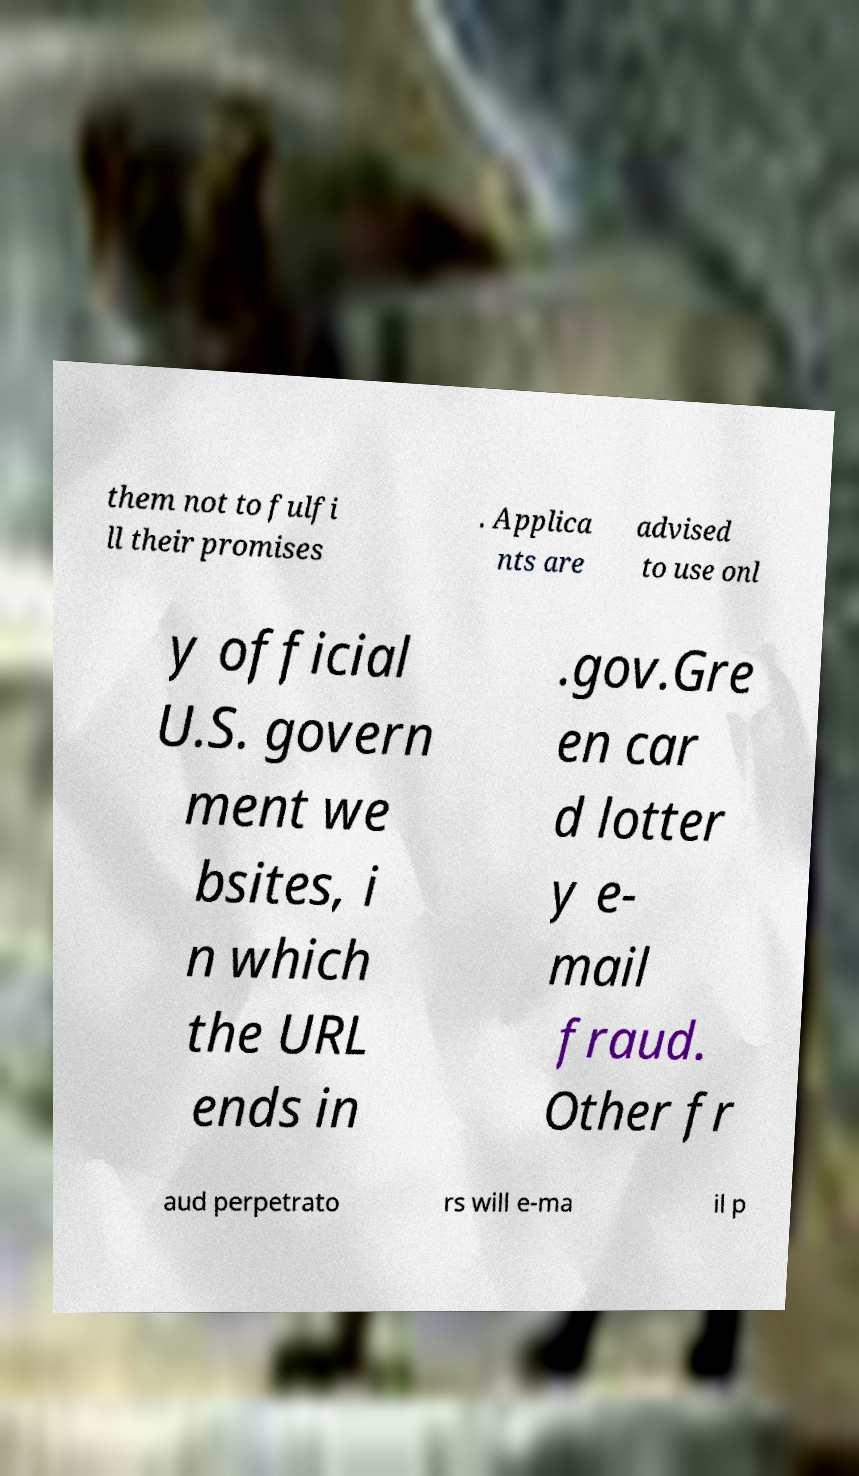Please read and relay the text visible in this image. What does it say? them not to fulfi ll their promises . Applica nts are advised to use onl y official U.S. govern ment we bsites, i n which the URL ends in .gov.Gre en car d lotter y e- mail fraud. Other fr aud perpetrato rs will e-ma il p 